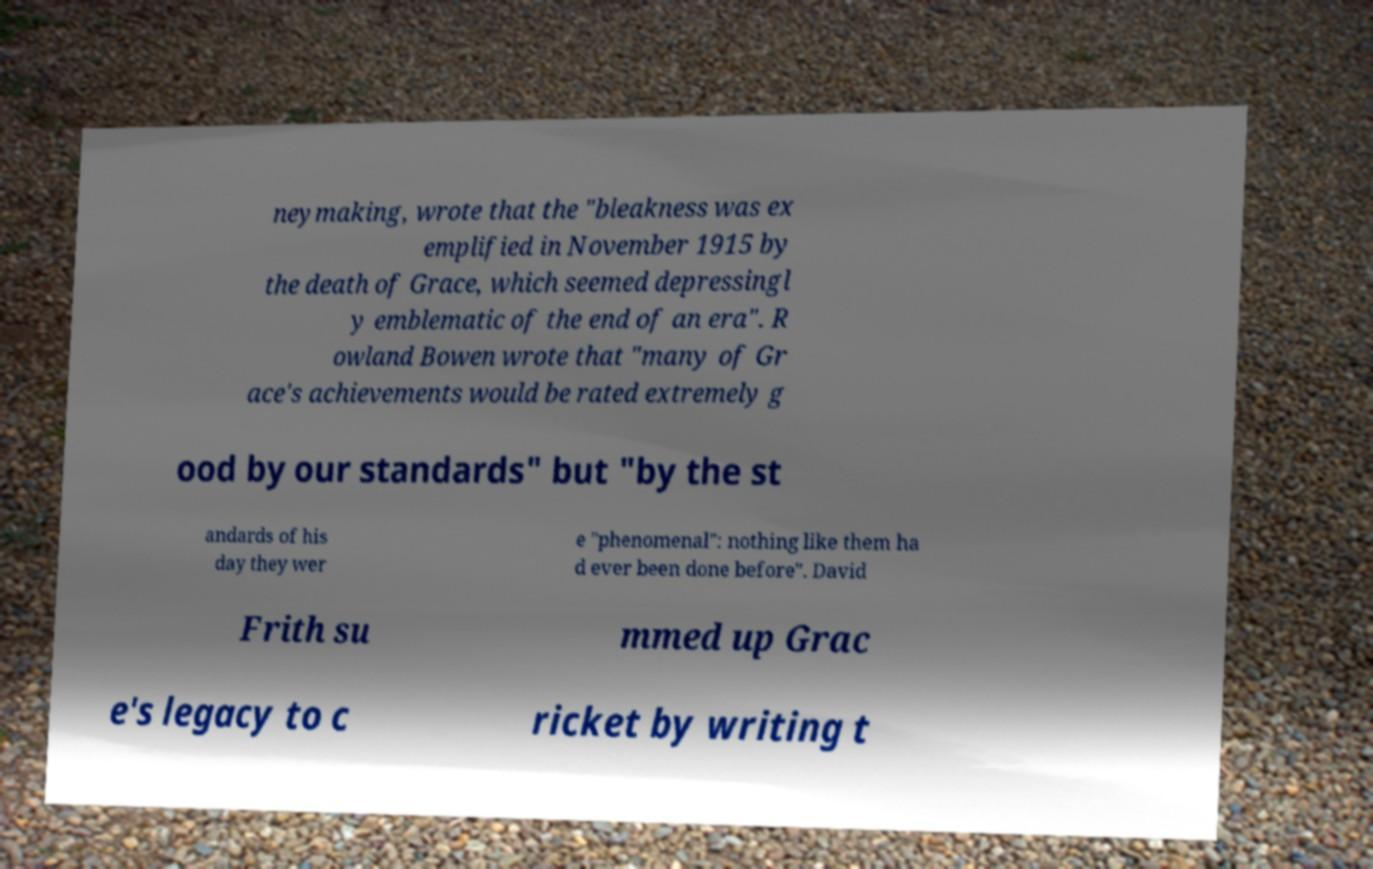Can you accurately transcribe the text from the provided image for me? neymaking, wrote that the "bleakness was ex emplified in November 1915 by the death of Grace, which seemed depressingl y emblematic of the end of an era". R owland Bowen wrote that "many of Gr ace's achievements would be rated extremely g ood by our standards" but "by the st andards of his day they wer e "phenomenal": nothing like them ha d ever been done before". David Frith su mmed up Grac e's legacy to c ricket by writing t 